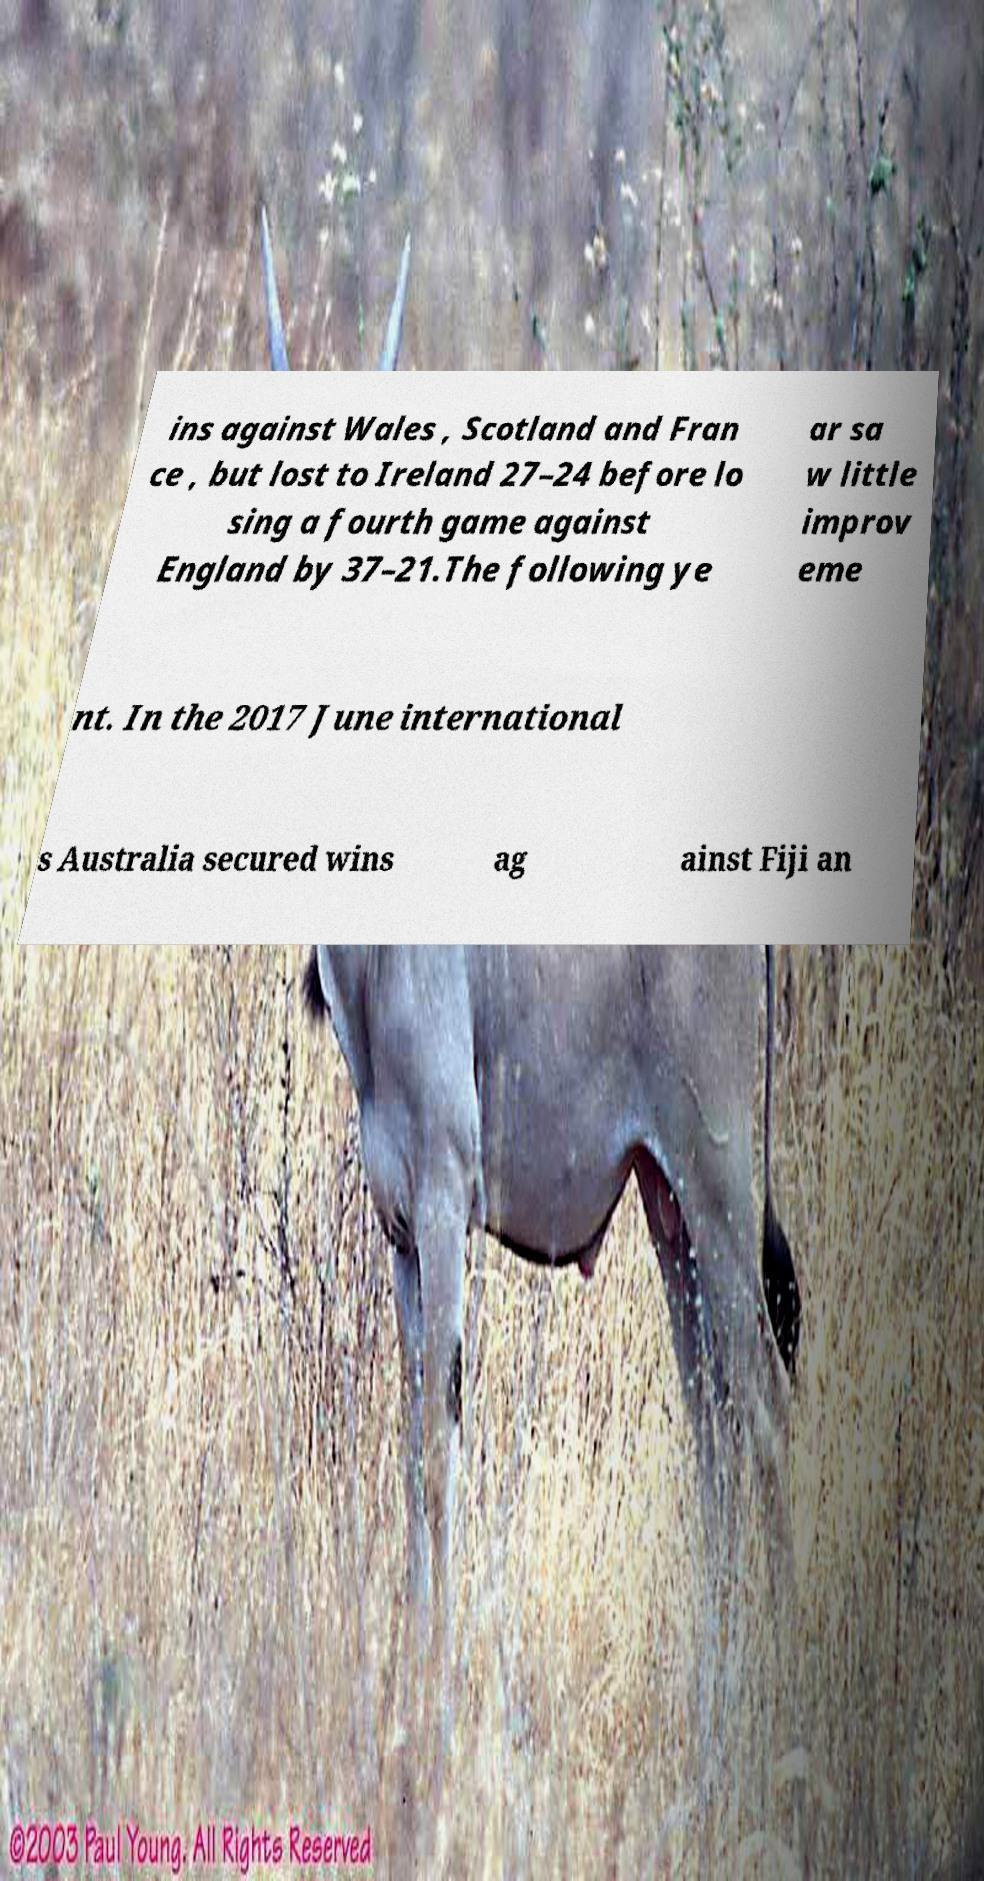Could you assist in decoding the text presented in this image and type it out clearly? ins against Wales , Scotland and Fran ce , but lost to Ireland 27–24 before lo sing a fourth game against England by 37–21.The following ye ar sa w little improv eme nt. In the 2017 June international s Australia secured wins ag ainst Fiji an 